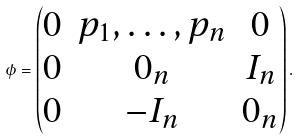Convert formula to latex. <formula><loc_0><loc_0><loc_500><loc_500>\phi = \begin{pmatrix} 0 & p _ { 1 } , \dots , p _ { n } & 0 \\ 0 & 0 _ { n } & I _ { n } \\ 0 & - I _ { n } & 0 _ { n } \end{pmatrix} .</formula> 